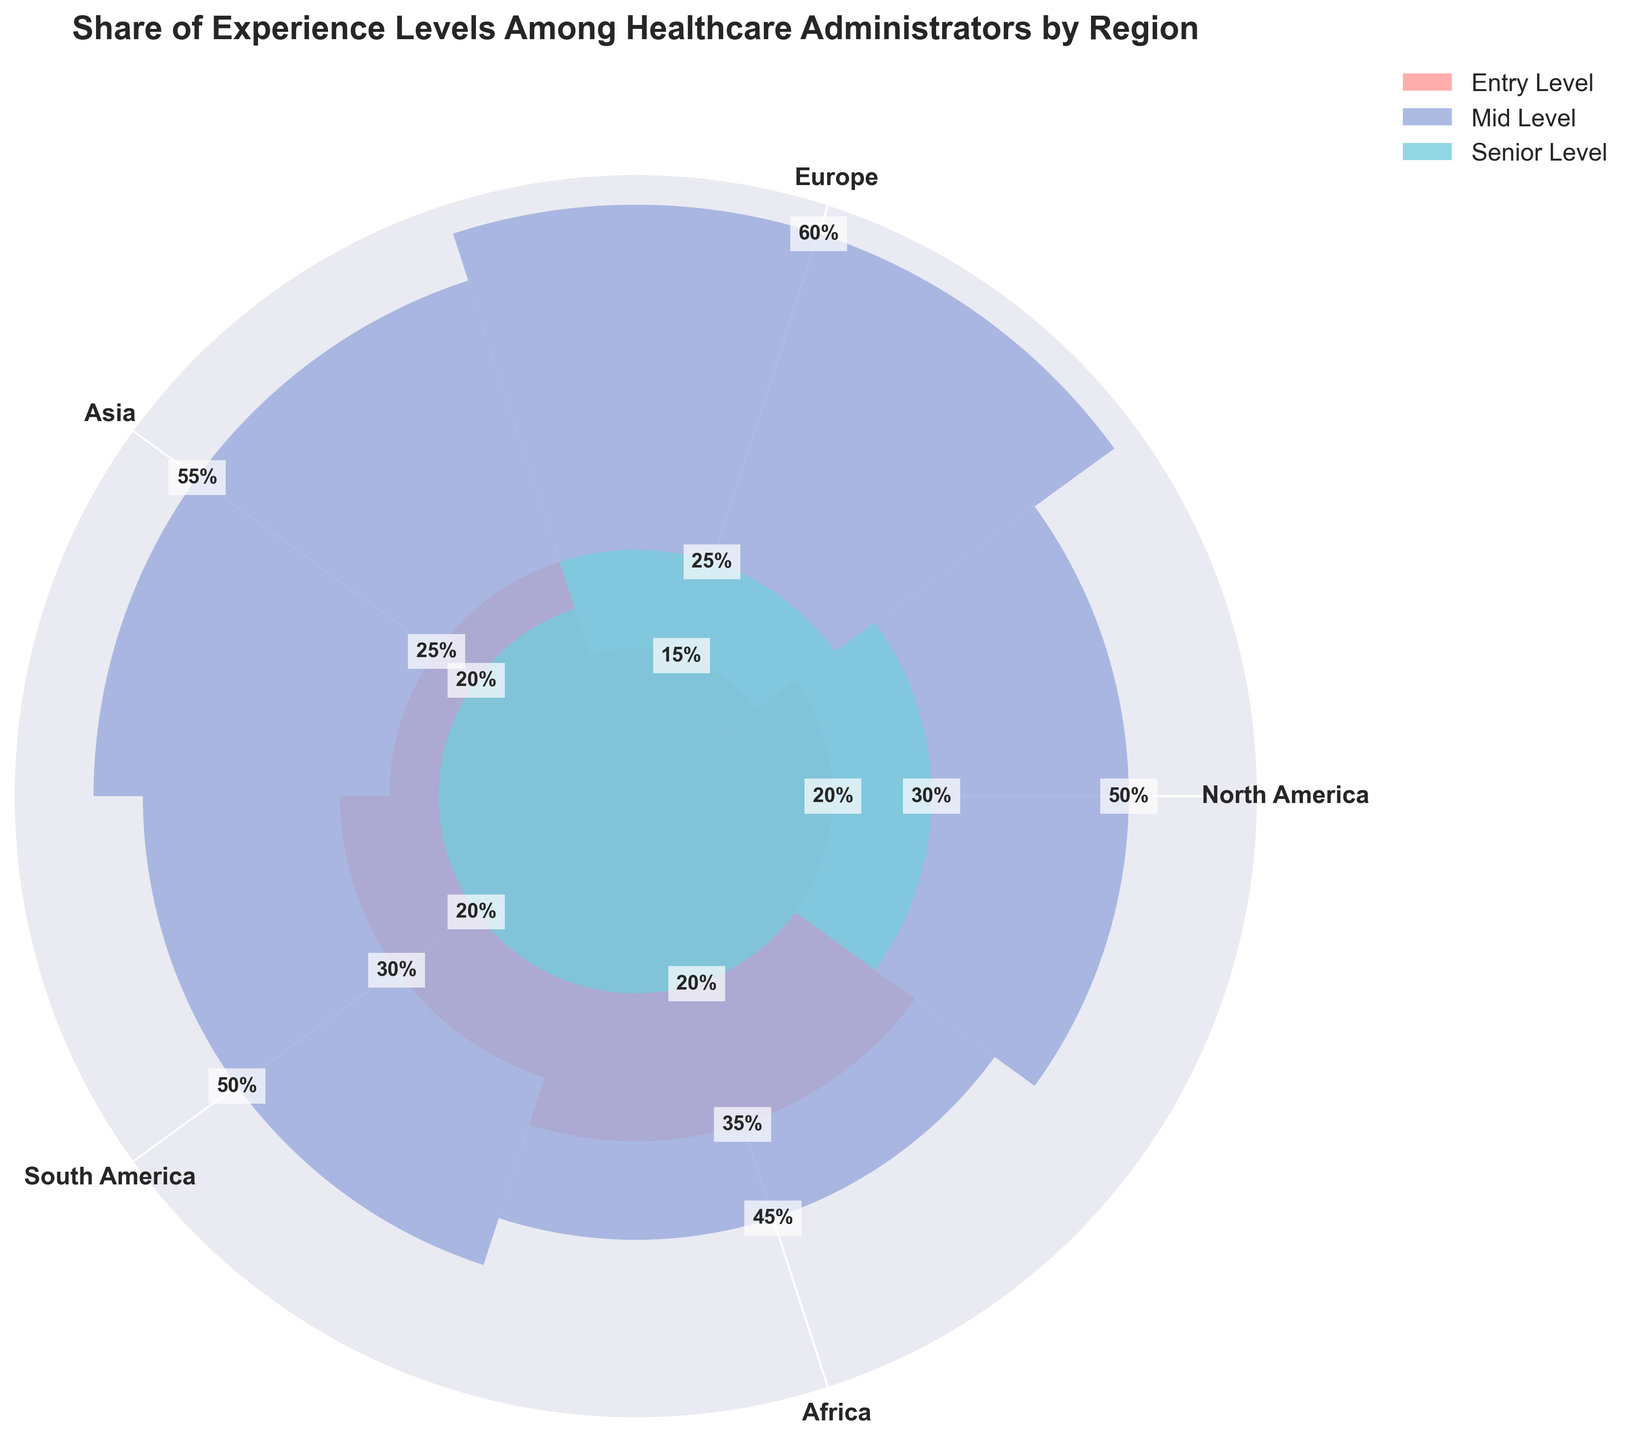What's the title of the chart? The title of the chart is usually displayed at the top and indicates the subject being visualized. In this case, the title reads "Share of Experience Levels Among Healthcare Administrators by Region."
Answer: Share of Experience Levels Among Healthcare Administrators by Region How many regions are represented in the chart? There are distinct labels along the perimeter of the rose chart, each representing a different region. Counting these labels gives us the number of regions.
Answer: Five Which experience level category has the highest share in Europe? Look for the region labeled "Europe" and examine the data points (segments) for "Entry Level," "Mid Level," and "Senior Level." The segment with the greatest percentage corresponds to the experience level with the highest share.
Answer: Mid Level What region has the highest share of Entry Level healthcare administrators? Check all the regions' segments for "Entry Level" and identify which one has the highest percentage.
Answer: Africa Which region has the lowest share of Senior Level healthcare administrators? Look for the smallest segment labeled "Senior Level" among all regions. This region has the lowest share.
Answer: Asia, South America, Africa (they all tie at 20%) Compare the share of Mid Level healthcare administrators between North America and Asia. Which region has a higher share? Compare the segments for "Mid Level" in the regions labeled "North America" and "Asia." The region with the larger segment has the higher share.
Answer: North America What is the average share of Entry Level healthcare administrators across all regions? Sum the percentages of "Entry Level" across all regions and then divide by the number of regions: (20 + 15 + 25 + 30 + 35) / 5 = 125 / 5.
Answer: 25% Is the share of Senior Level healthcare administrators in Europe higher or lower than in North America? Compare the percentage of the "Senior Level" segment in "Europe" with that in "North America." Europe has 25% and North America has 30%.
Answer: Lower Which experience level has the most uniform distribution across the regions? Examine the variation in the segment sizes for each experience level across all regions. The experience level with the least variation is the most uniformly distributed.
Answer: Senior Level What is the combined share of Entry Level and Mid Level healthcare administrators in South America? Add the percentages for "Entry Level" and "Mid Level" in the region labeled "South America." Entry Level is 30% and Mid Level is 50%. Combining these gives us 30 + 50.
Answer: 80% 